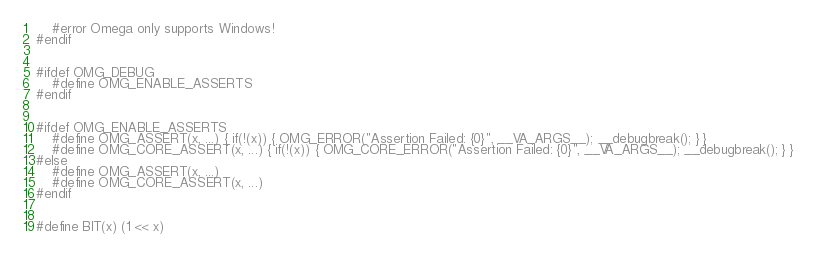<code> <loc_0><loc_0><loc_500><loc_500><_C_>	#error Omega only supports Windows!
#endif


#ifdef OMG_DEBUG
	#define OMG_ENABLE_ASSERTS
#endif


#ifdef OMG_ENABLE_ASSERTS
	#define OMG_ASSERT(x, ...) { if(!(x)) { OMG_ERROR("Assertion Failed: {0}", __VA_ARGS__); __debugbreak(); } }
	#define OMG_CORE_ASSERT(x, ...) { if(!(x)) { OMG_CORE_ERROR("Assertion Failed: {0}", __VA_ARGS__); __debugbreak(); } }
#else
	#define OMG_ASSERT(x, ...)
	#define OMG_CORE_ASSERT(x, ...)
#endif


#define BIT(x) (1 << x)</code> 